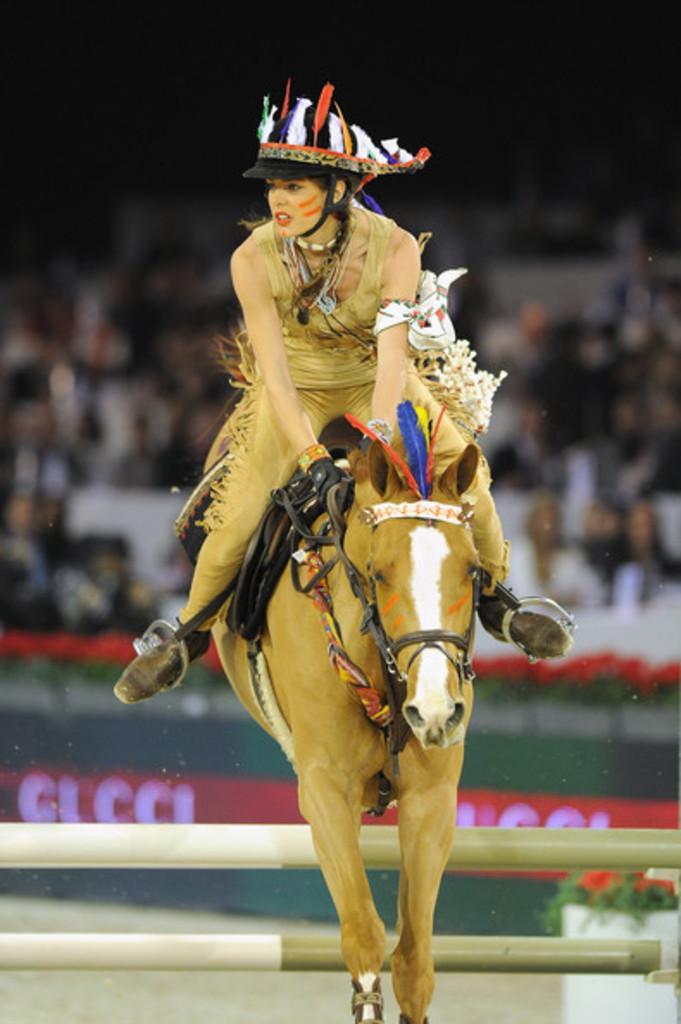Could you give a brief overview of what you see in this image? In this picture there is a girl at the center of the image who is riding a horse, it seems to be a playground and there are audience behind the girl at the center of the image. 